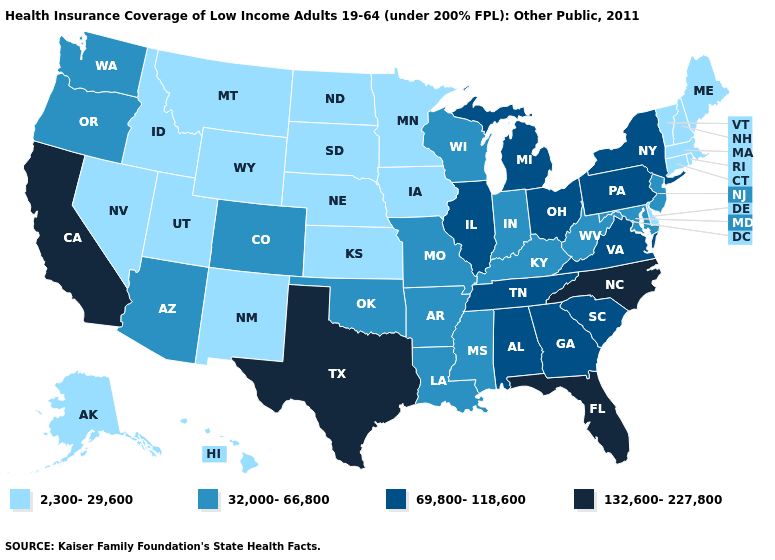What is the value of Ohio?
Give a very brief answer. 69,800-118,600. Name the states that have a value in the range 132,600-227,800?
Short answer required. California, Florida, North Carolina, Texas. Does Florida have the lowest value in the South?
Concise answer only. No. Name the states that have a value in the range 2,300-29,600?
Quick response, please. Alaska, Connecticut, Delaware, Hawaii, Idaho, Iowa, Kansas, Maine, Massachusetts, Minnesota, Montana, Nebraska, Nevada, New Hampshire, New Mexico, North Dakota, Rhode Island, South Dakota, Utah, Vermont, Wyoming. What is the value of Texas?
Be succinct. 132,600-227,800. What is the value of Iowa?
Give a very brief answer. 2,300-29,600. Name the states that have a value in the range 69,800-118,600?
Short answer required. Alabama, Georgia, Illinois, Michigan, New York, Ohio, Pennsylvania, South Carolina, Tennessee, Virginia. Does Nebraska have the lowest value in the MidWest?
Be succinct. Yes. Name the states that have a value in the range 2,300-29,600?
Short answer required. Alaska, Connecticut, Delaware, Hawaii, Idaho, Iowa, Kansas, Maine, Massachusetts, Minnesota, Montana, Nebraska, Nevada, New Hampshire, New Mexico, North Dakota, Rhode Island, South Dakota, Utah, Vermont, Wyoming. Is the legend a continuous bar?
Write a very short answer. No. Which states hav the highest value in the MidWest?
Give a very brief answer. Illinois, Michigan, Ohio. Does Oregon have the lowest value in the West?
Write a very short answer. No. Name the states that have a value in the range 2,300-29,600?
Quick response, please. Alaska, Connecticut, Delaware, Hawaii, Idaho, Iowa, Kansas, Maine, Massachusetts, Minnesota, Montana, Nebraska, Nevada, New Hampshire, New Mexico, North Dakota, Rhode Island, South Dakota, Utah, Vermont, Wyoming. What is the highest value in states that border Arkansas?
Be succinct. 132,600-227,800. 